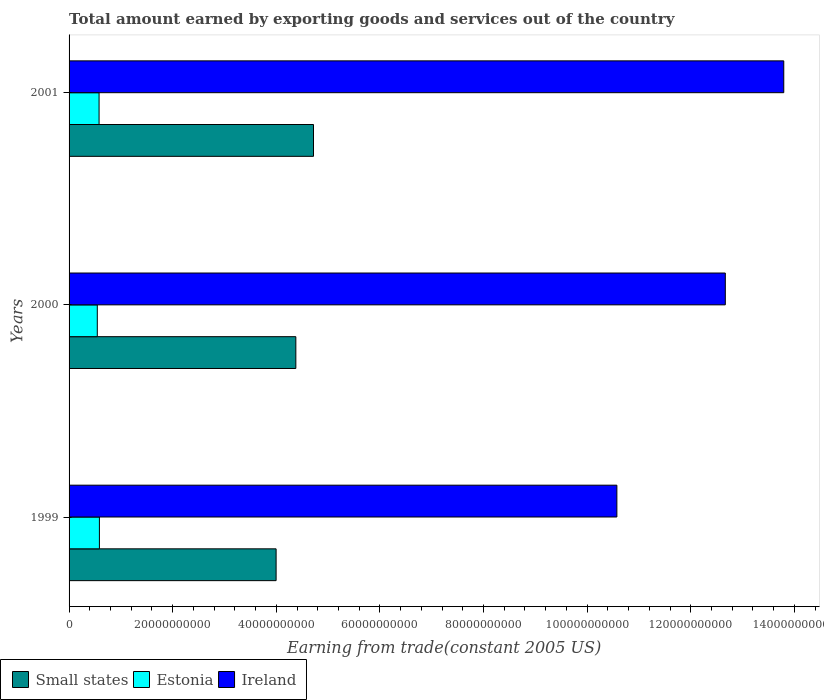Are the number of bars on each tick of the Y-axis equal?
Offer a very short reply. Yes. How many bars are there on the 3rd tick from the bottom?
Keep it short and to the point. 3. What is the label of the 2nd group of bars from the top?
Your response must be concise. 2000. In how many cases, is the number of bars for a given year not equal to the number of legend labels?
Give a very brief answer. 0. What is the total amount earned by exporting goods and services in Small states in 2001?
Offer a terse response. 4.72e+1. Across all years, what is the maximum total amount earned by exporting goods and services in Ireland?
Make the answer very short. 1.38e+11. Across all years, what is the minimum total amount earned by exporting goods and services in Ireland?
Provide a short and direct response. 1.06e+11. What is the total total amount earned by exporting goods and services in Ireland in the graph?
Offer a terse response. 3.70e+11. What is the difference between the total amount earned by exporting goods and services in Estonia in 1999 and that in 2000?
Ensure brevity in your answer.  4.07e+08. What is the difference between the total amount earned by exporting goods and services in Ireland in 2001 and the total amount earned by exporting goods and services in Estonia in 1999?
Provide a short and direct response. 1.32e+11. What is the average total amount earned by exporting goods and services in Estonia per year?
Provide a short and direct response. 5.70e+09. In the year 2000, what is the difference between the total amount earned by exporting goods and services in Ireland and total amount earned by exporting goods and services in Small states?
Your response must be concise. 8.29e+1. In how many years, is the total amount earned by exporting goods and services in Estonia greater than 28000000000 US$?
Offer a terse response. 0. What is the ratio of the total amount earned by exporting goods and services in Ireland in 1999 to that in 2000?
Offer a terse response. 0.83. What is the difference between the highest and the second highest total amount earned by exporting goods and services in Estonia?
Offer a terse response. 6.19e+07. What is the difference between the highest and the lowest total amount earned by exporting goods and services in Ireland?
Keep it short and to the point. 3.22e+1. In how many years, is the total amount earned by exporting goods and services in Small states greater than the average total amount earned by exporting goods and services in Small states taken over all years?
Offer a terse response. 2. Is the sum of the total amount earned by exporting goods and services in Estonia in 1999 and 2001 greater than the maximum total amount earned by exporting goods and services in Ireland across all years?
Provide a short and direct response. No. What does the 3rd bar from the top in 2001 represents?
Provide a short and direct response. Small states. What does the 3rd bar from the bottom in 2001 represents?
Your answer should be very brief. Ireland. Is it the case that in every year, the sum of the total amount earned by exporting goods and services in Estonia and total amount earned by exporting goods and services in Small states is greater than the total amount earned by exporting goods and services in Ireland?
Your answer should be compact. No. How many bars are there?
Your answer should be very brief. 9. Are all the bars in the graph horizontal?
Keep it short and to the point. Yes. How many years are there in the graph?
Keep it short and to the point. 3. What is the difference between two consecutive major ticks on the X-axis?
Offer a terse response. 2.00e+1. Are the values on the major ticks of X-axis written in scientific E-notation?
Your response must be concise. No. Does the graph contain any zero values?
Give a very brief answer. No. What is the title of the graph?
Your response must be concise. Total amount earned by exporting goods and services out of the country. Does "Argentina" appear as one of the legend labels in the graph?
Give a very brief answer. No. What is the label or title of the X-axis?
Offer a very short reply. Earning from trade(constant 2005 US). What is the label or title of the Y-axis?
Ensure brevity in your answer.  Years. What is the Earning from trade(constant 2005 US) in Small states in 1999?
Your answer should be compact. 4.00e+1. What is the Earning from trade(constant 2005 US) of Estonia in 1999?
Your answer should be very brief. 5.86e+09. What is the Earning from trade(constant 2005 US) in Ireland in 1999?
Ensure brevity in your answer.  1.06e+11. What is the Earning from trade(constant 2005 US) in Small states in 2000?
Offer a very short reply. 4.38e+1. What is the Earning from trade(constant 2005 US) in Estonia in 2000?
Your answer should be very brief. 5.45e+09. What is the Earning from trade(constant 2005 US) of Ireland in 2000?
Ensure brevity in your answer.  1.27e+11. What is the Earning from trade(constant 2005 US) of Small states in 2001?
Your response must be concise. 4.72e+1. What is the Earning from trade(constant 2005 US) of Estonia in 2001?
Offer a terse response. 5.79e+09. What is the Earning from trade(constant 2005 US) of Ireland in 2001?
Keep it short and to the point. 1.38e+11. Across all years, what is the maximum Earning from trade(constant 2005 US) of Small states?
Offer a terse response. 4.72e+1. Across all years, what is the maximum Earning from trade(constant 2005 US) of Estonia?
Make the answer very short. 5.86e+09. Across all years, what is the maximum Earning from trade(constant 2005 US) of Ireland?
Keep it short and to the point. 1.38e+11. Across all years, what is the minimum Earning from trade(constant 2005 US) in Small states?
Your answer should be very brief. 4.00e+1. Across all years, what is the minimum Earning from trade(constant 2005 US) in Estonia?
Offer a very short reply. 5.45e+09. Across all years, what is the minimum Earning from trade(constant 2005 US) in Ireland?
Offer a terse response. 1.06e+11. What is the total Earning from trade(constant 2005 US) of Small states in the graph?
Ensure brevity in your answer.  1.31e+11. What is the total Earning from trade(constant 2005 US) in Estonia in the graph?
Offer a very short reply. 1.71e+1. What is the total Earning from trade(constant 2005 US) of Ireland in the graph?
Provide a succinct answer. 3.70e+11. What is the difference between the Earning from trade(constant 2005 US) in Small states in 1999 and that in 2000?
Offer a very short reply. -3.81e+09. What is the difference between the Earning from trade(constant 2005 US) in Estonia in 1999 and that in 2000?
Your answer should be very brief. 4.07e+08. What is the difference between the Earning from trade(constant 2005 US) of Ireland in 1999 and that in 2000?
Provide a succinct answer. -2.09e+1. What is the difference between the Earning from trade(constant 2005 US) of Small states in 1999 and that in 2001?
Offer a terse response. -7.22e+09. What is the difference between the Earning from trade(constant 2005 US) in Estonia in 1999 and that in 2001?
Offer a terse response. 6.19e+07. What is the difference between the Earning from trade(constant 2005 US) in Ireland in 1999 and that in 2001?
Your answer should be very brief. -3.22e+1. What is the difference between the Earning from trade(constant 2005 US) of Small states in 2000 and that in 2001?
Provide a succinct answer. -3.41e+09. What is the difference between the Earning from trade(constant 2005 US) in Estonia in 2000 and that in 2001?
Your answer should be compact. -3.45e+08. What is the difference between the Earning from trade(constant 2005 US) of Ireland in 2000 and that in 2001?
Your response must be concise. -1.13e+1. What is the difference between the Earning from trade(constant 2005 US) in Small states in 1999 and the Earning from trade(constant 2005 US) in Estonia in 2000?
Your answer should be compact. 3.45e+1. What is the difference between the Earning from trade(constant 2005 US) in Small states in 1999 and the Earning from trade(constant 2005 US) in Ireland in 2000?
Your answer should be compact. -8.67e+1. What is the difference between the Earning from trade(constant 2005 US) of Estonia in 1999 and the Earning from trade(constant 2005 US) of Ireland in 2000?
Your answer should be compact. -1.21e+11. What is the difference between the Earning from trade(constant 2005 US) of Small states in 1999 and the Earning from trade(constant 2005 US) of Estonia in 2001?
Give a very brief answer. 3.42e+1. What is the difference between the Earning from trade(constant 2005 US) in Small states in 1999 and the Earning from trade(constant 2005 US) in Ireland in 2001?
Offer a very short reply. -9.80e+1. What is the difference between the Earning from trade(constant 2005 US) in Estonia in 1999 and the Earning from trade(constant 2005 US) in Ireland in 2001?
Provide a succinct answer. -1.32e+11. What is the difference between the Earning from trade(constant 2005 US) of Small states in 2000 and the Earning from trade(constant 2005 US) of Estonia in 2001?
Your response must be concise. 3.80e+1. What is the difference between the Earning from trade(constant 2005 US) in Small states in 2000 and the Earning from trade(constant 2005 US) in Ireland in 2001?
Ensure brevity in your answer.  -9.42e+1. What is the difference between the Earning from trade(constant 2005 US) of Estonia in 2000 and the Earning from trade(constant 2005 US) of Ireland in 2001?
Give a very brief answer. -1.33e+11. What is the average Earning from trade(constant 2005 US) of Small states per year?
Your answer should be very brief. 4.36e+1. What is the average Earning from trade(constant 2005 US) in Estonia per year?
Your answer should be very brief. 5.70e+09. What is the average Earning from trade(constant 2005 US) in Ireland per year?
Your answer should be very brief. 1.23e+11. In the year 1999, what is the difference between the Earning from trade(constant 2005 US) of Small states and Earning from trade(constant 2005 US) of Estonia?
Provide a short and direct response. 3.41e+1. In the year 1999, what is the difference between the Earning from trade(constant 2005 US) in Small states and Earning from trade(constant 2005 US) in Ireland?
Your response must be concise. -6.58e+1. In the year 1999, what is the difference between the Earning from trade(constant 2005 US) of Estonia and Earning from trade(constant 2005 US) of Ireland?
Give a very brief answer. -9.99e+1. In the year 2000, what is the difference between the Earning from trade(constant 2005 US) in Small states and Earning from trade(constant 2005 US) in Estonia?
Give a very brief answer. 3.83e+1. In the year 2000, what is the difference between the Earning from trade(constant 2005 US) in Small states and Earning from trade(constant 2005 US) in Ireland?
Keep it short and to the point. -8.29e+1. In the year 2000, what is the difference between the Earning from trade(constant 2005 US) of Estonia and Earning from trade(constant 2005 US) of Ireland?
Provide a short and direct response. -1.21e+11. In the year 2001, what is the difference between the Earning from trade(constant 2005 US) in Small states and Earning from trade(constant 2005 US) in Estonia?
Your response must be concise. 4.14e+1. In the year 2001, what is the difference between the Earning from trade(constant 2005 US) of Small states and Earning from trade(constant 2005 US) of Ireland?
Keep it short and to the point. -9.08e+1. In the year 2001, what is the difference between the Earning from trade(constant 2005 US) of Estonia and Earning from trade(constant 2005 US) of Ireland?
Keep it short and to the point. -1.32e+11. What is the ratio of the Earning from trade(constant 2005 US) of Estonia in 1999 to that in 2000?
Make the answer very short. 1.07. What is the ratio of the Earning from trade(constant 2005 US) in Ireland in 1999 to that in 2000?
Make the answer very short. 0.83. What is the ratio of the Earning from trade(constant 2005 US) in Small states in 1999 to that in 2001?
Provide a short and direct response. 0.85. What is the ratio of the Earning from trade(constant 2005 US) in Estonia in 1999 to that in 2001?
Provide a short and direct response. 1.01. What is the ratio of the Earning from trade(constant 2005 US) in Ireland in 1999 to that in 2001?
Your answer should be very brief. 0.77. What is the ratio of the Earning from trade(constant 2005 US) in Small states in 2000 to that in 2001?
Offer a terse response. 0.93. What is the ratio of the Earning from trade(constant 2005 US) of Estonia in 2000 to that in 2001?
Give a very brief answer. 0.94. What is the ratio of the Earning from trade(constant 2005 US) of Ireland in 2000 to that in 2001?
Provide a succinct answer. 0.92. What is the difference between the highest and the second highest Earning from trade(constant 2005 US) in Small states?
Provide a short and direct response. 3.41e+09. What is the difference between the highest and the second highest Earning from trade(constant 2005 US) in Estonia?
Make the answer very short. 6.19e+07. What is the difference between the highest and the second highest Earning from trade(constant 2005 US) of Ireland?
Ensure brevity in your answer.  1.13e+1. What is the difference between the highest and the lowest Earning from trade(constant 2005 US) of Small states?
Give a very brief answer. 7.22e+09. What is the difference between the highest and the lowest Earning from trade(constant 2005 US) of Estonia?
Give a very brief answer. 4.07e+08. What is the difference between the highest and the lowest Earning from trade(constant 2005 US) of Ireland?
Give a very brief answer. 3.22e+1. 